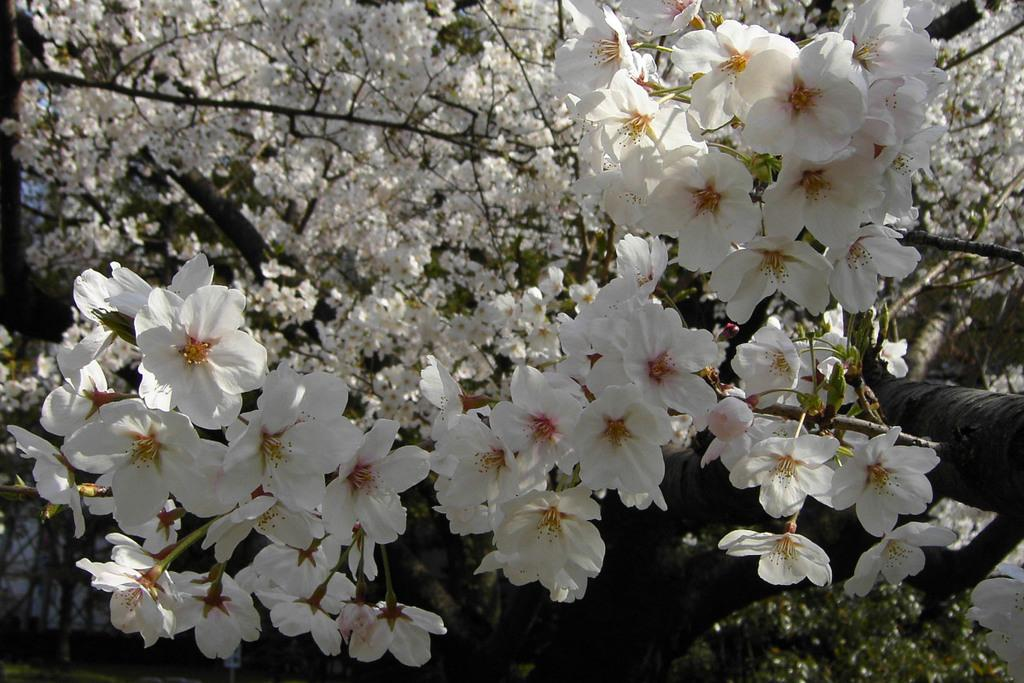What type of vegetation can be seen in the image? There are trees in the image. What specific feature of the trees is visible? The trees have flowers. What color are the flowers on the trees? The flowers are white in color. What type of meeting is taking place in the image? There is no meeting present in the image; it features trees with white flowers. What territory is depicted in the image? The image does not depict a specific territory; it simply shows trees with white flowers. 